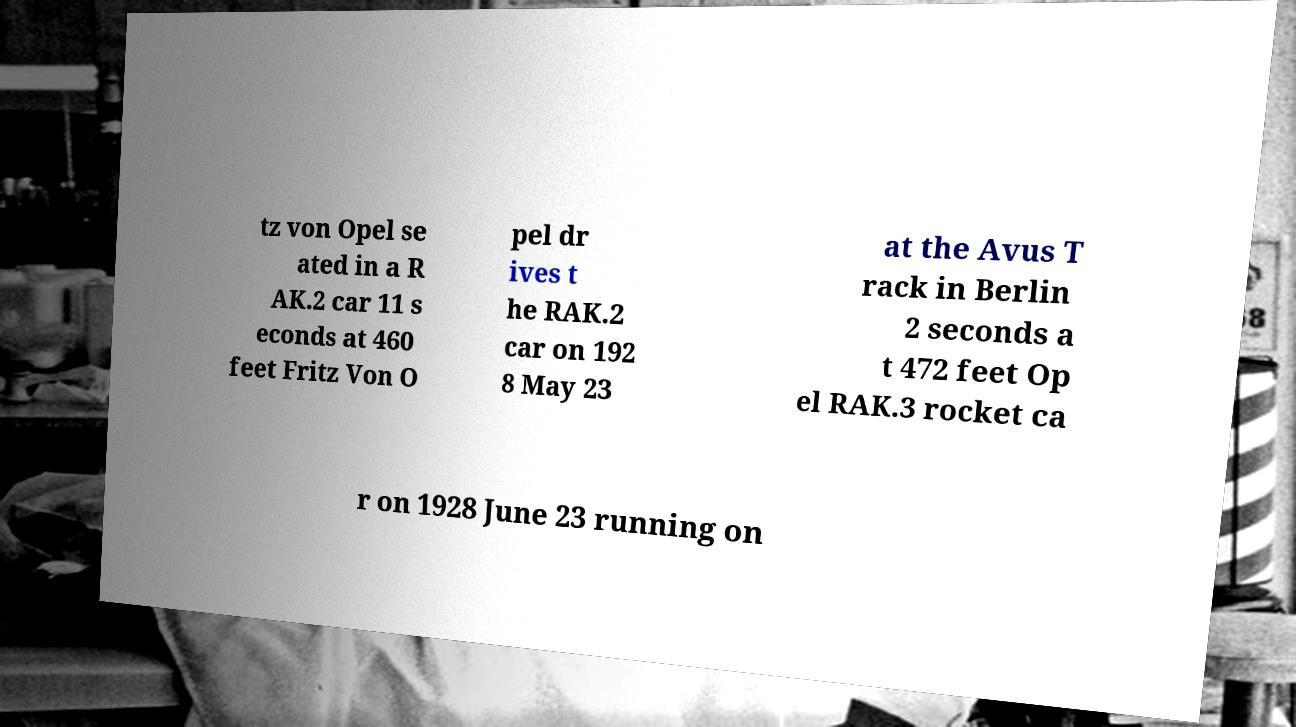Can you accurately transcribe the text from the provided image for me? tz von Opel se ated in a R AK.2 car 11 s econds at 460 feet Fritz Von O pel dr ives t he RAK.2 car on 192 8 May 23 at the Avus T rack in Berlin 2 seconds a t 472 feet Op el RAK.3 rocket ca r on 1928 June 23 running on 